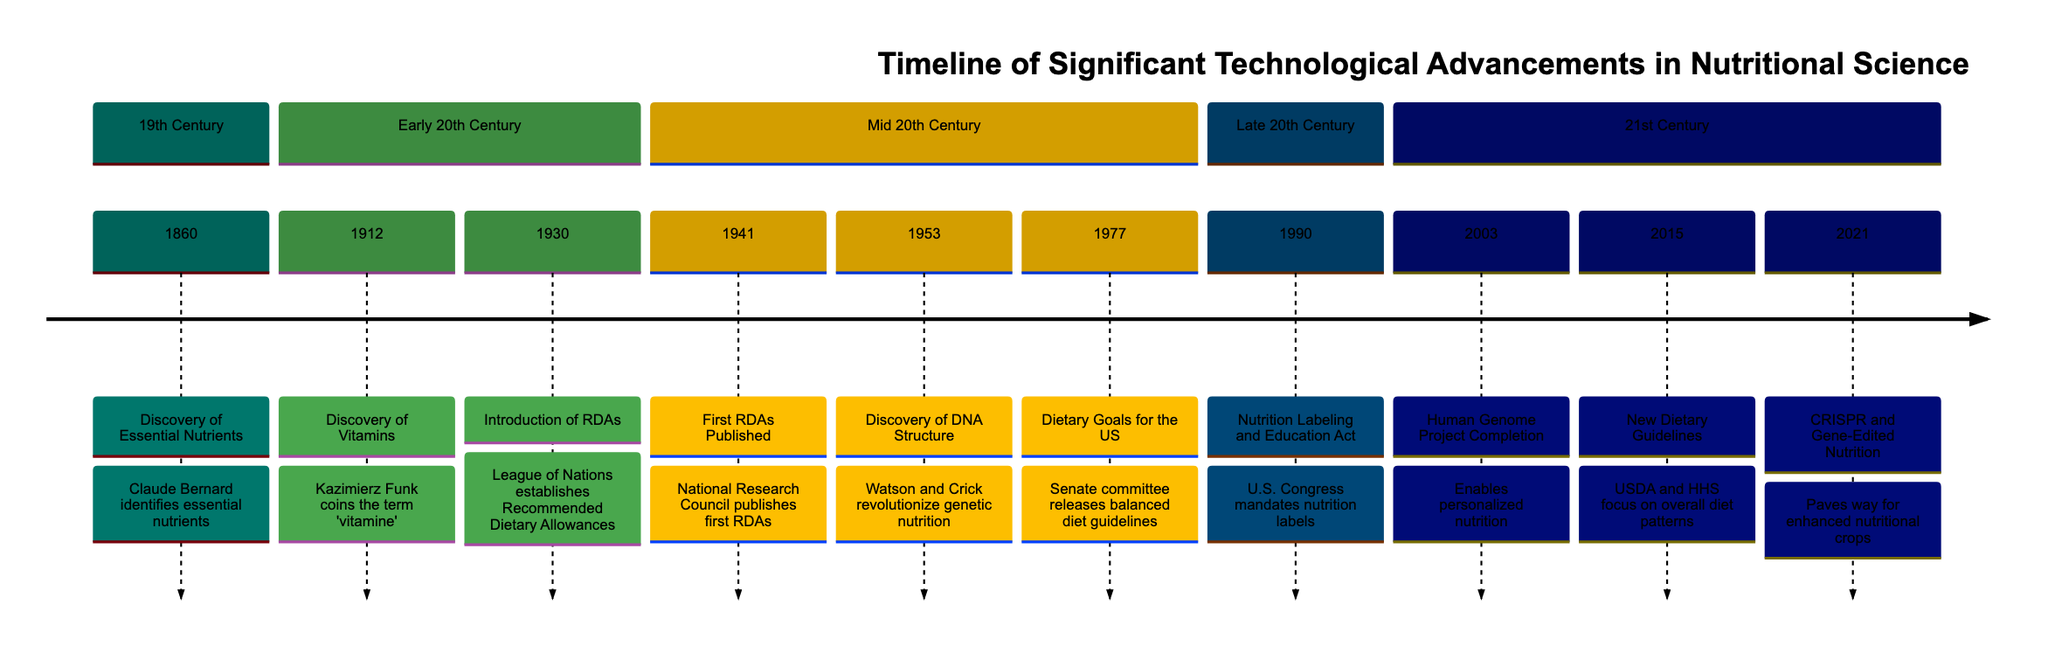What year did the discovery of essential nutrients occur? The diagram indicates that the discovery of essential nutrients took place in the year 1860, which is explicitly stated next to the event.
Answer: 1860 Who coined the term 'vitamine'? According to the timeline, Kazimierz Funk is credited with coining the term 'vitamine' in 1912, highlighted in the description of that event.
Answer: Kazimierz Funk What significant event happened in 2003? The timeline outlines that in 2003, the Human Genome Project was completed, marking a pivotal advancement in nutritional science.
Answer: Human Genome Project Completion Which two events are associated with dietary guidelines in the United States? The timeline includes both "Dietary Goals for the United States" in 1977 and "USDA and HHS Release New Dietary Guidelines" in 2015 as events focusing on dietary guidelines, requiring the connection between these two entries to answer the question.
Answer: Dietary Goals for the United States and New Dietary Guidelines What technological advancement occurred immediately after the introduction of RDAs? The diagram shows that the introduction of Recommended Dietary Allowances (RDAs) in 1930 was followed by the publication of the first RDAs in 1941, establishing a chronological relationship that helps answer the question.
Answer: First RDAs Published How many major advancements in nutritional science occurred before the year 2000? By counting the events listed in the timeline prior to 2000, we find a total of six significant advancements (comprising the events in the 19th and 20th centuries).
Answer: 6 Which advancement focuses on genetic editing for nutrition? The diagram clearly outlines that in 2021, CRISPR and Gene-Edited Nutrition emerged as a significant advancement focusing on utilizing genetic technology to improve nutritional profiles.
Answer: CRISPR and Gene-Edited Nutrition What year signifies the establishment of the first RDAs? According to the timeline, the first RDAs were published in 1941, as noted in the event description.
Answer: 1941 What is the common theme of advancements from 2003 onward? The common theme for the advancements from 2003 onward is personalized nutrition and the integration of technology in dietary practices, reflecting a shift toward individualized dietary approaches and biotechnology.
Answer: Personalized nutrition and technology integration 